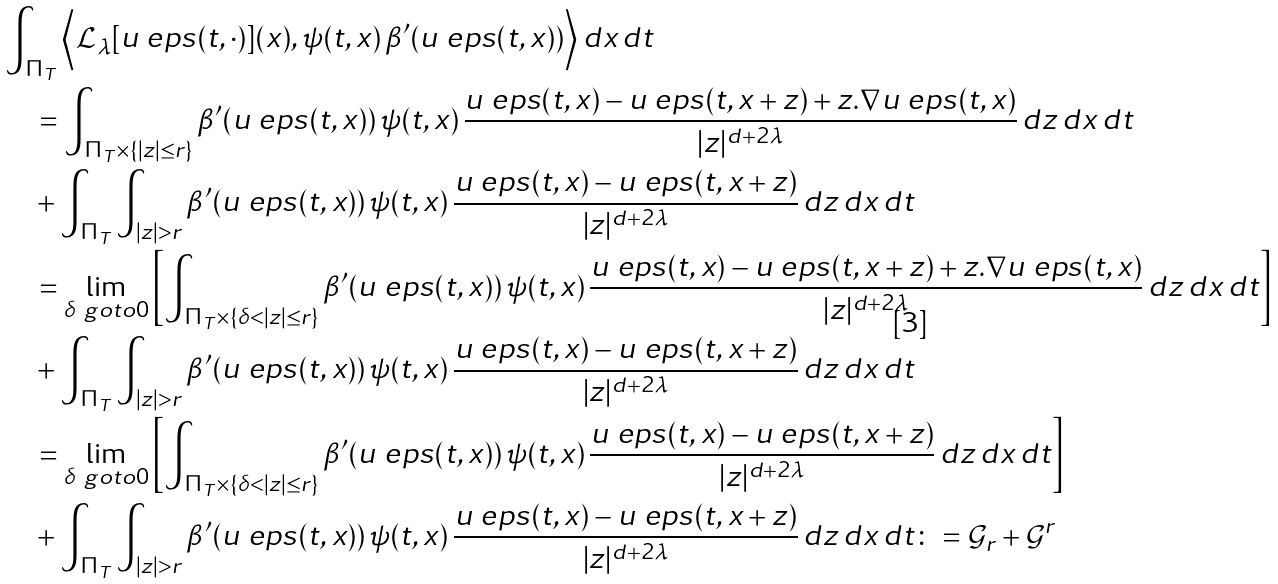Convert formula to latex. <formula><loc_0><loc_0><loc_500><loc_500>& \int _ { \Pi _ { T } } \Big < \mathcal { L } _ { \lambda } [ u _ { \ } e p s ( t , \cdot ) ] ( x ) , \psi ( t , x ) \, \beta ^ { \prime } ( u _ { \ } e p s ( t , x ) ) \Big > \, d x \, d t \\ & \quad = \int _ { \Pi _ { T } \times \{ | z | \leq r \} } \beta ^ { \prime } ( u _ { \ } e p s ( t , x ) ) \, \psi ( t , x ) \, \frac { u _ { \ } e p s ( t , x ) - u _ { \ } e p s ( t , x + z ) + z . \nabla u _ { \ } e p s ( t , x ) } { | z | ^ { d + 2 \lambda } } \, d z \, d x \, d t \\ & \quad + \int _ { \Pi _ { T } } \int _ { | z | > r } \beta ^ { \prime } ( u _ { \ } e p s ( t , x ) ) \, \psi ( t , x ) \, \frac { u _ { \ } e p s ( t , x ) - u _ { \ } e p s ( t , x + z ) } { | z | ^ { d + 2 \lambda } } \, d z \, d x \, d t \\ & \quad = \lim _ { \delta \ g o t o 0 } \left [ \int _ { \Pi _ { T } \times \{ \delta < | z | \leq r \} } \beta ^ { \prime } ( u _ { \ } e p s ( t , x ) ) \, \psi ( t , x ) \, \frac { u _ { \ } e p s ( t , x ) - u _ { \ } e p s ( t , x + z ) + z . \nabla u _ { \ } e p s ( t , x ) } { | z | ^ { d + 2 \lambda } } \, d z \, d x \, d t \right ] \\ & \quad + \int _ { \Pi _ { T } } \int _ { | z | > r } \beta ^ { \prime } ( u _ { \ } e p s ( t , x ) ) \, \psi ( t , x ) \, \frac { u _ { \ } e p s ( t , x ) - u _ { \ } e p s ( t , x + z ) } { | z | ^ { d + 2 \lambda } } \, d z \, d x \, d t \\ & \quad = \lim _ { \delta \ g o t o 0 } \left [ \int _ { \Pi _ { T } \times \{ \delta < | z | \leq r \} } \beta ^ { \prime } ( u _ { \ } e p s ( t , x ) ) \, \psi ( t , x ) \, \frac { u _ { \ } e p s ( t , x ) - u _ { \ } e p s ( t , x + z ) } { | z | ^ { d + 2 \lambda } } \, d z \, d x \, d t \right ] \\ & \quad + \int _ { \Pi _ { T } } \int _ { | z | > r } \beta ^ { \prime } ( u _ { \ } e p s ( t , x ) ) \, \psi ( t , x ) \, \frac { u _ { \ } e p s ( t , x ) - u _ { \ } e p s ( t , x + z ) } { | z | ^ { d + 2 \lambda } } \, d z \, d x \, d t \colon = \mathcal { G } _ { r } + \mathcal { G } ^ { r }</formula> 